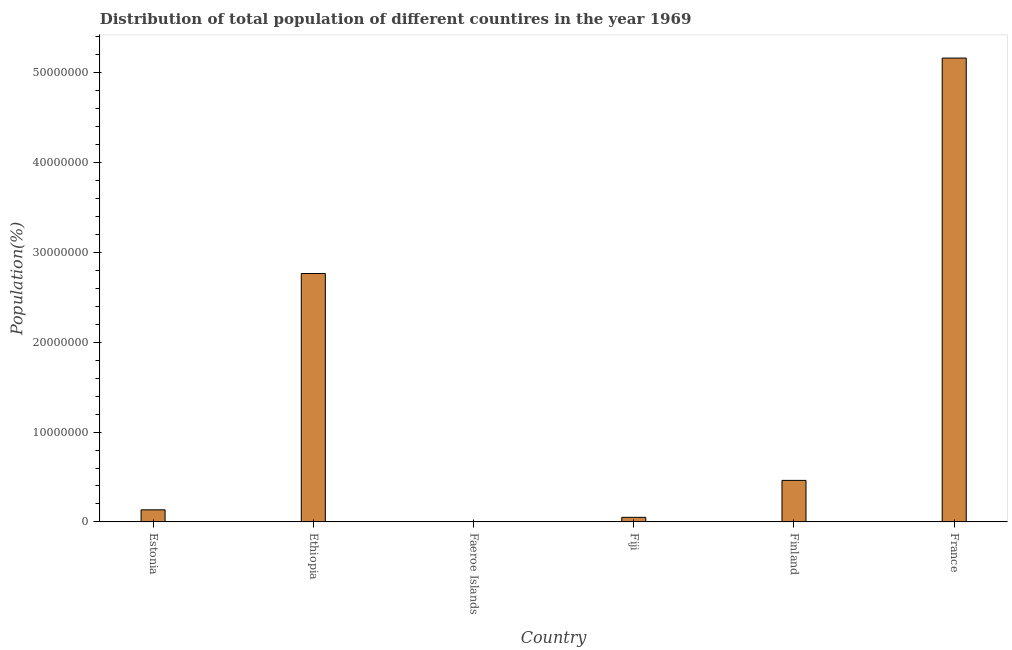What is the title of the graph?
Give a very brief answer. Distribution of total population of different countires in the year 1969. What is the label or title of the X-axis?
Ensure brevity in your answer.  Country. What is the label or title of the Y-axis?
Offer a very short reply. Population(%). What is the population in Estonia?
Provide a succinct answer. 1.35e+06. Across all countries, what is the maximum population?
Make the answer very short. 5.16e+07. Across all countries, what is the minimum population?
Ensure brevity in your answer.  3.82e+04. In which country was the population minimum?
Provide a short and direct response. Faeroe Islands. What is the sum of the population?
Provide a succinct answer. 8.58e+07. What is the difference between the population in Estonia and Fiji?
Offer a terse response. 8.36e+05. What is the average population per country?
Your answer should be very brief. 1.43e+07. What is the median population?
Offer a very short reply. 2.98e+06. What is the ratio of the population in Estonia to that in Ethiopia?
Give a very brief answer. 0.05. Is the population in Estonia less than that in Finland?
Provide a short and direct response. Yes. What is the difference between the highest and the second highest population?
Offer a terse response. 2.40e+07. What is the difference between the highest and the lowest population?
Your answer should be compact. 5.16e+07. In how many countries, is the population greater than the average population taken over all countries?
Offer a very short reply. 2. How many bars are there?
Provide a succinct answer. 6. What is the difference between two consecutive major ticks on the Y-axis?
Ensure brevity in your answer.  1.00e+07. Are the values on the major ticks of Y-axis written in scientific E-notation?
Give a very brief answer. No. What is the Population(%) in Estonia?
Provide a short and direct response. 1.35e+06. What is the Population(%) in Ethiopia?
Your response must be concise. 2.77e+07. What is the Population(%) of Faeroe Islands?
Give a very brief answer. 3.82e+04. What is the Population(%) of Fiji?
Your answer should be very brief. 5.10e+05. What is the Population(%) in Finland?
Your response must be concise. 4.62e+06. What is the Population(%) in France?
Offer a terse response. 5.16e+07. What is the difference between the Population(%) in Estonia and Ethiopia?
Provide a short and direct response. -2.63e+07. What is the difference between the Population(%) in Estonia and Faeroe Islands?
Give a very brief answer. 1.31e+06. What is the difference between the Population(%) in Estonia and Fiji?
Offer a very short reply. 8.36e+05. What is the difference between the Population(%) in Estonia and Finland?
Make the answer very short. -3.28e+06. What is the difference between the Population(%) in Estonia and France?
Give a very brief answer. -5.03e+07. What is the difference between the Population(%) in Ethiopia and Faeroe Islands?
Make the answer very short. 2.76e+07. What is the difference between the Population(%) in Ethiopia and Fiji?
Offer a very short reply. 2.71e+07. What is the difference between the Population(%) in Ethiopia and Finland?
Give a very brief answer. 2.30e+07. What is the difference between the Population(%) in Ethiopia and France?
Make the answer very short. -2.40e+07. What is the difference between the Population(%) in Faeroe Islands and Fiji?
Keep it short and to the point. -4.71e+05. What is the difference between the Population(%) in Faeroe Islands and Finland?
Your response must be concise. -4.59e+06. What is the difference between the Population(%) in Faeroe Islands and France?
Your answer should be very brief. -5.16e+07. What is the difference between the Population(%) in Fiji and Finland?
Ensure brevity in your answer.  -4.11e+06. What is the difference between the Population(%) in Fiji and France?
Keep it short and to the point. -5.11e+07. What is the difference between the Population(%) in Finland and France?
Offer a terse response. -4.70e+07. What is the ratio of the Population(%) in Estonia to that in Ethiopia?
Your response must be concise. 0.05. What is the ratio of the Population(%) in Estonia to that in Faeroe Islands?
Your answer should be compact. 35.25. What is the ratio of the Population(%) in Estonia to that in Fiji?
Provide a short and direct response. 2.64. What is the ratio of the Population(%) in Estonia to that in Finland?
Offer a terse response. 0.29. What is the ratio of the Population(%) in Estonia to that in France?
Make the answer very short. 0.03. What is the ratio of the Population(%) in Ethiopia to that in Faeroe Islands?
Your response must be concise. 724.6. What is the ratio of the Population(%) in Ethiopia to that in Fiji?
Ensure brevity in your answer.  54.26. What is the ratio of the Population(%) in Ethiopia to that in Finland?
Give a very brief answer. 5.98. What is the ratio of the Population(%) in Ethiopia to that in France?
Your answer should be very brief. 0.54. What is the ratio of the Population(%) in Faeroe Islands to that in Fiji?
Your answer should be very brief. 0.07. What is the ratio of the Population(%) in Faeroe Islands to that in Finland?
Your response must be concise. 0.01. What is the ratio of the Population(%) in Faeroe Islands to that in France?
Ensure brevity in your answer.  0. What is the ratio of the Population(%) in Fiji to that in Finland?
Ensure brevity in your answer.  0.11. What is the ratio of the Population(%) in Finland to that in France?
Offer a very short reply. 0.09. 